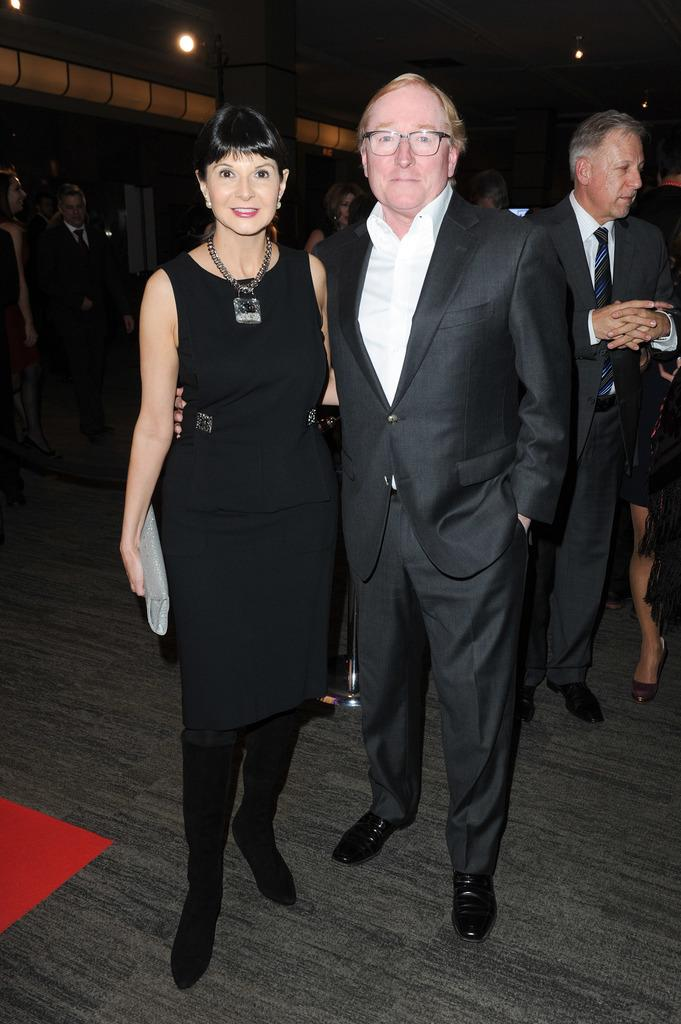How many people are in the image? There are two people in the image, a man and a woman. What is the woman wearing in the image? The woman is wearing a black dress. What is the man wearing in the image? The man is wearing a black blazer and a white shirt. What type of hand can be seen holding a light in the image? There is no hand or light present in the image. Can you describe the rabbit in the image? There is no rabbit present in the image. 